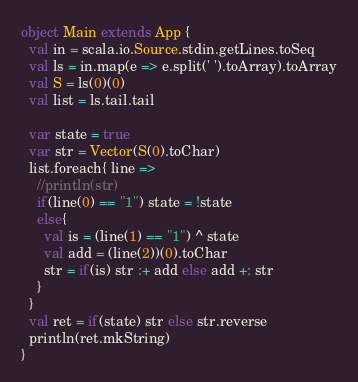Convert code to text. <code><loc_0><loc_0><loc_500><loc_500><_Scala_>object Main extends App {
  val in = scala.io.Source.stdin.getLines.toSeq
  val ls = in.map(e => e.split(' ').toArray).toArray
  val S = ls(0)(0)
  val list = ls.tail.tail
  
  var state = true
  var str = Vector(S(0).toChar)
  list.foreach{ line =>
    //println(str)
    if(line(0) == "1") state = !state
    else{
      val is = (line(1) == "1") ^ state
      val add = (line(2))(0).toChar
      str = if(is) str :+ add else add +: str
    }
  }
  val ret = if(state) str else str.reverse
  println(ret.mkString)
}
</code> 